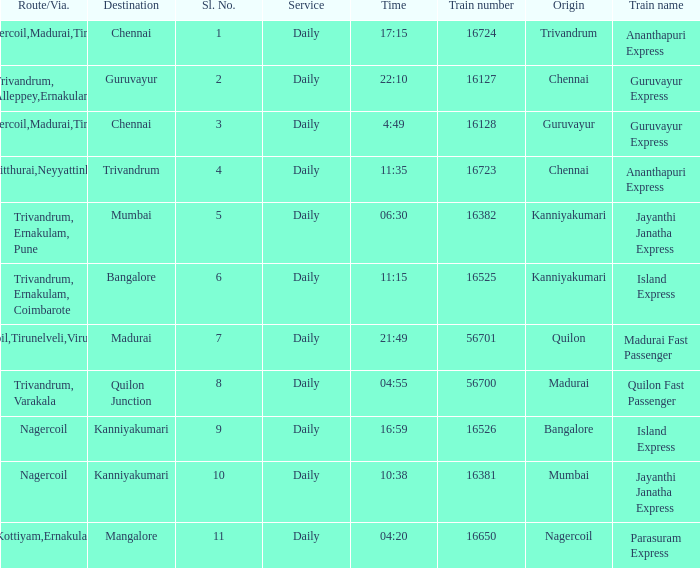What is the route/via when the train name is Parasuram Express? Trivandrum,Kottiyam,Ernakulam,Kozhikode. 